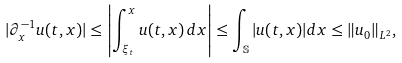<formula> <loc_0><loc_0><loc_500><loc_500>| \partial _ { x } ^ { - 1 } u ( t , x ) | \leq \left | \int _ { \xi _ { t } } ^ { x } u ( t , x ) \, d x \right | \leq \int _ { \mathbb { S } } | u ( t , x ) | d x \leq \| u _ { 0 } \| _ { L ^ { 2 } } ,</formula> 